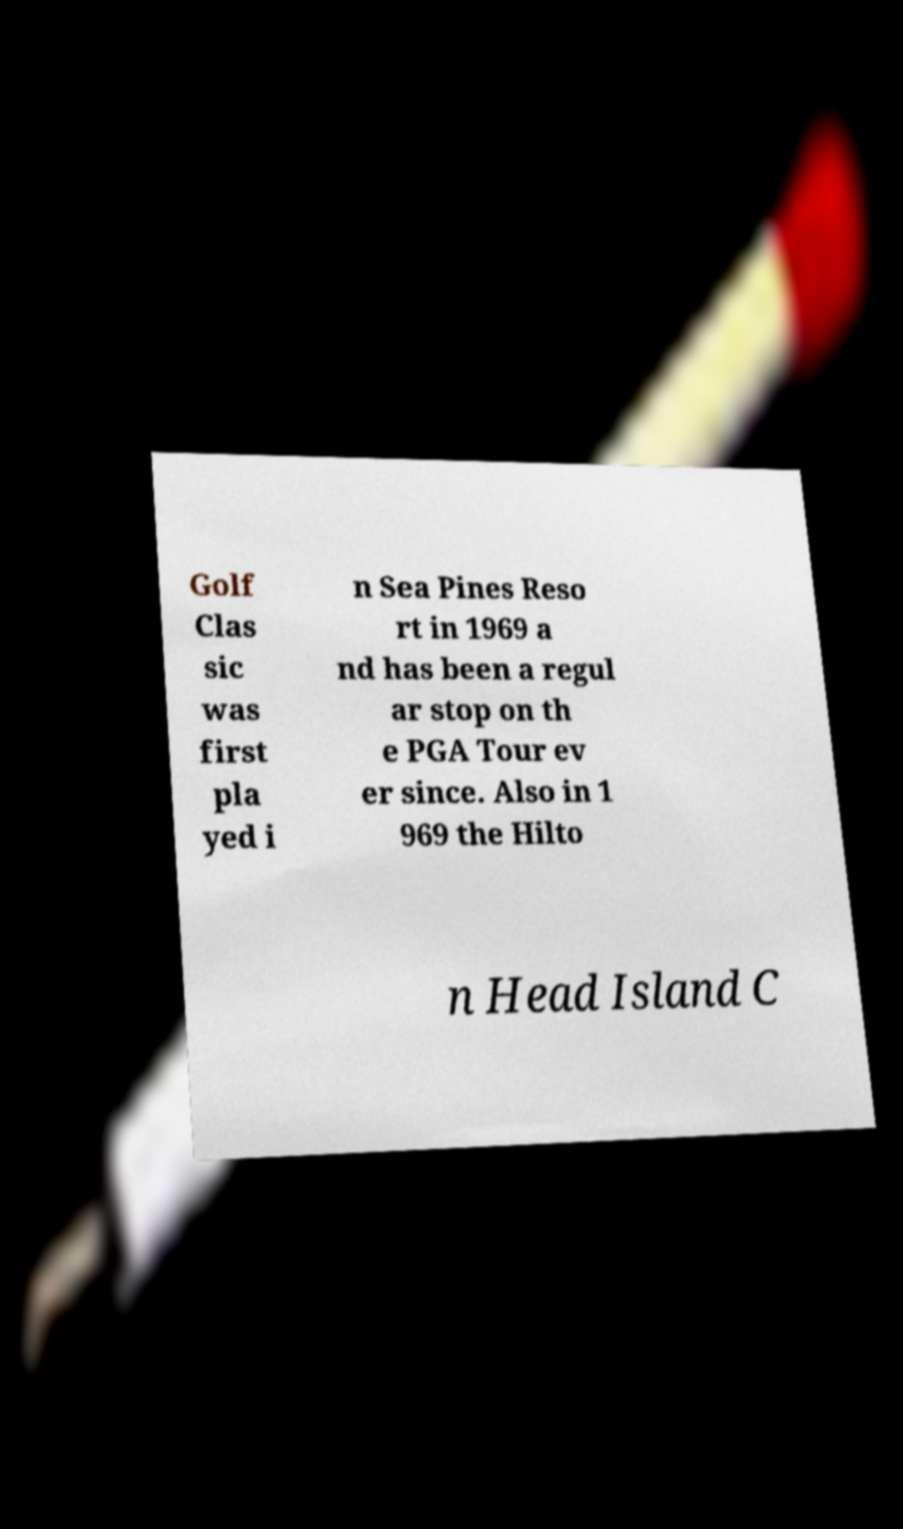Could you extract and type out the text from this image? Golf Clas sic was first pla yed i n Sea Pines Reso rt in 1969 a nd has been a regul ar stop on th e PGA Tour ev er since. Also in 1 969 the Hilto n Head Island C 